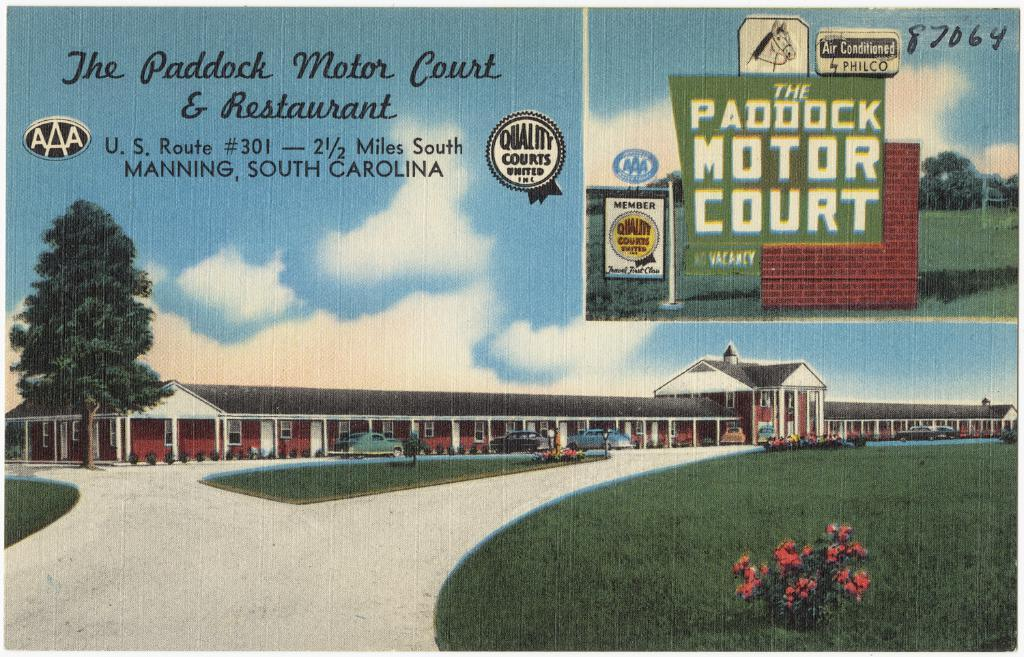<image>
Present a compact description of the photo's key features. A drawing showing the Paddock Motor Court and Restaurant. 